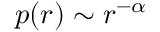Convert formula to latex. <formula><loc_0><loc_0><loc_500><loc_500>p ( r ) \sim r ^ { - \alpha }</formula> 